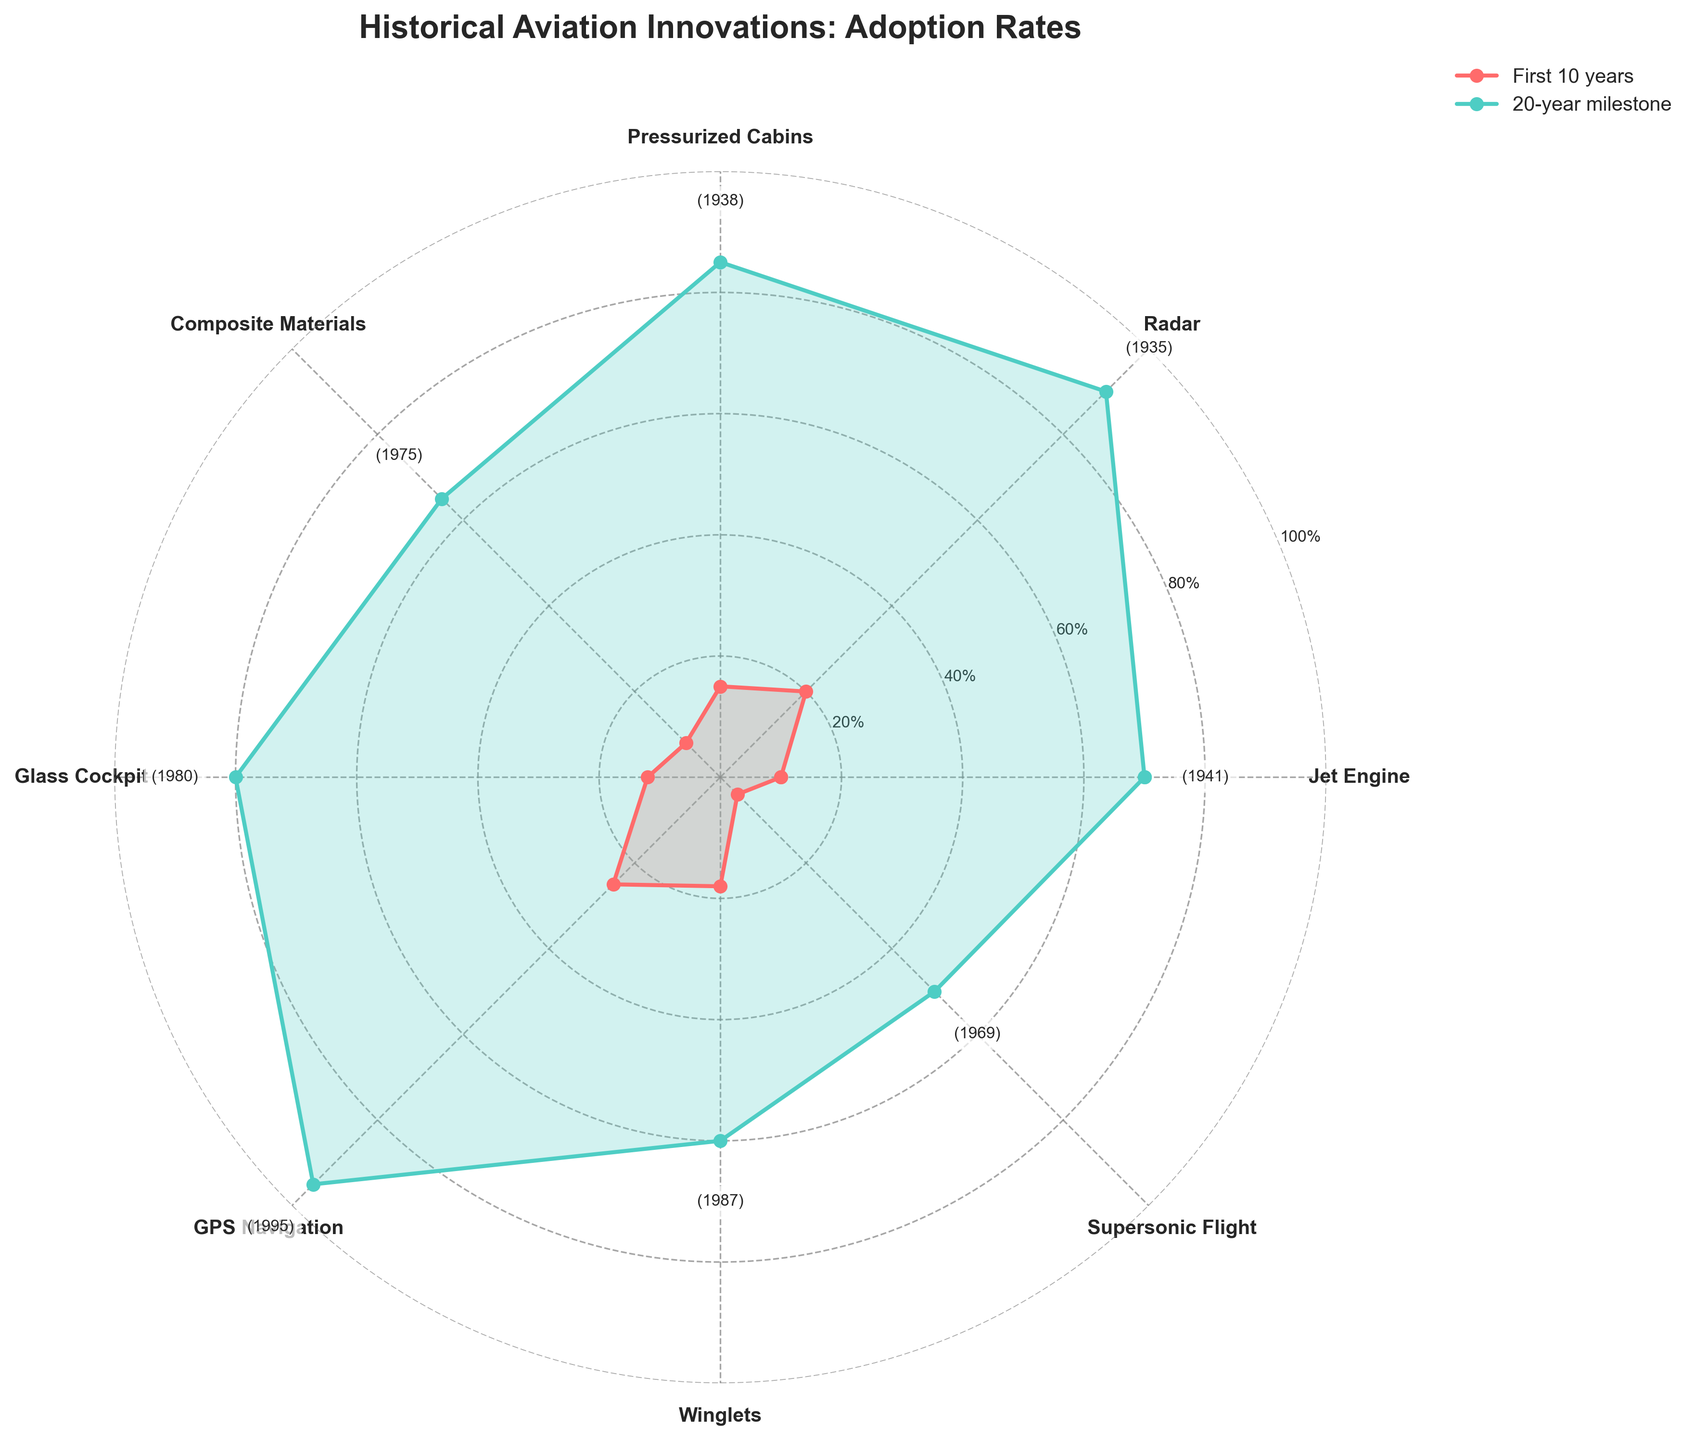What's the title of the rose chart? The title of the figure is located at the top center of the chart in bold font. It reads "Historical Aviation Innovations: Adoption Rates".
Answer: Historical Aviation Innovations: Adoption Rates Which innovation shows the highest adoption rate at the 20-year milestone? By examining the green-filled areas and lines that represent the 20-year milestone, the highest point belongs to GPS Navigation which reaches 95%.
Answer: GPS Navigation How many innovations are represented in the rose chart? By counting the number of different sections or angles labeled with innovation names on the outer ring of the chart, we can see there are 8 innovations shown.
Answer: 8 Compare the adoption rate of Pressurized Cabins and Winglets in the first 10 years. Which one is higher? The red-filled areas and lines display the adoption rate at the first 10 years. Comparing Pressurized Cabins and Winglets, Pressurized Cabins have an adoption rate of 15% while Winglets have 18%. Winglets have a higher adoption rate.
Answer: Winglets What is the average adoption rate of the Jet Engine at both milestones? The adoption rates of Jet Engine at the first 10 years and the 20-year milestone are 10% and 70%, respectively. Calculating the average: (10% + 70%) / 2 = 40%.
Answer: 40% Which innovation experienced the largest increase in adoption rate from the first 10 years to the 20-year milestone? To find this, we calculate the difference between the 20-year milestone and the first 10 years for each innovation and identify the largest increase. Radar increased from 20% to 90% (a 70% increase).
Answer: Radar What is the color representing the adoption rate at the first 10 years in the chart? The chart uses red-filled areas and lines to represent adoption rates in the first 10 years.
Answer: Red List the innovations with an adoption rate of 60% or more at the 20-year milestone. By looking at the green-filled areas and lines, innovations with 60% or higher adoption rate are Jet Engine, Radar, Pressurized Cabins, Glass Cockpit, and GPS Navigation.
Answer: Jet Engine, Radar, Pressurized Cabins, Glass Cockpit, GPS Navigation Which innovation had the lowest adoption rate in the first 10 years? The smallest red-filled region or the line closest to the center determines the lowest adoption rate, which is for Supersonic Flight with 4%.
Answer: Supersonic Flight 